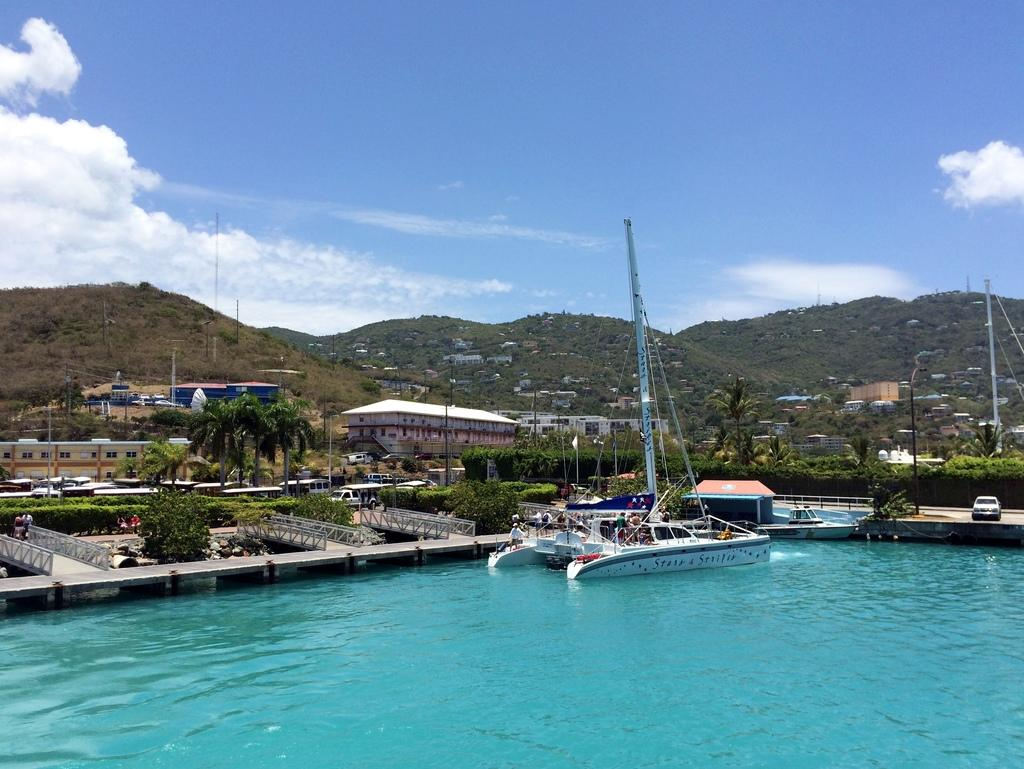What is on the water in the image? There are boats on the water in the image. What can be seen in the distance behind the boats? There are buildings, trees, plants, vehicles, mountains, and the sky visible in the background of the image. Can you describe the unspecified objects in the background? Unfortunately, the provided facts do not specify the nature of these objects, so it is not possible to describe them. Where is the school located in the image? There is no school present in the image. What type of cart is being used to transport the plants in the image? There is no cart present in the image; plants are visible in the background, but no cart is mentioned. 